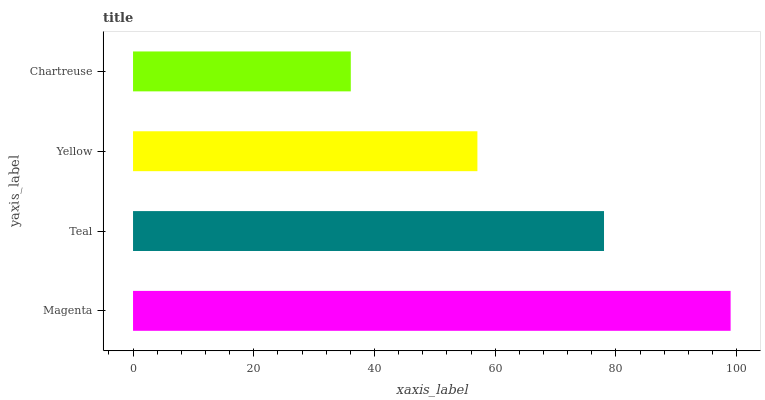Is Chartreuse the minimum?
Answer yes or no. Yes. Is Magenta the maximum?
Answer yes or no. Yes. Is Teal the minimum?
Answer yes or no. No. Is Teal the maximum?
Answer yes or no. No. Is Magenta greater than Teal?
Answer yes or no. Yes. Is Teal less than Magenta?
Answer yes or no. Yes. Is Teal greater than Magenta?
Answer yes or no. No. Is Magenta less than Teal?
Answer yes or no. No. Is Teal the high median?
Answer yes or no. Yes. Is Yellow the low median?
Answer yes or no. Yes. Is Yellow the high median?
Answer yes or no. No. Is Teal the low median?
Answer yes or no. No. 